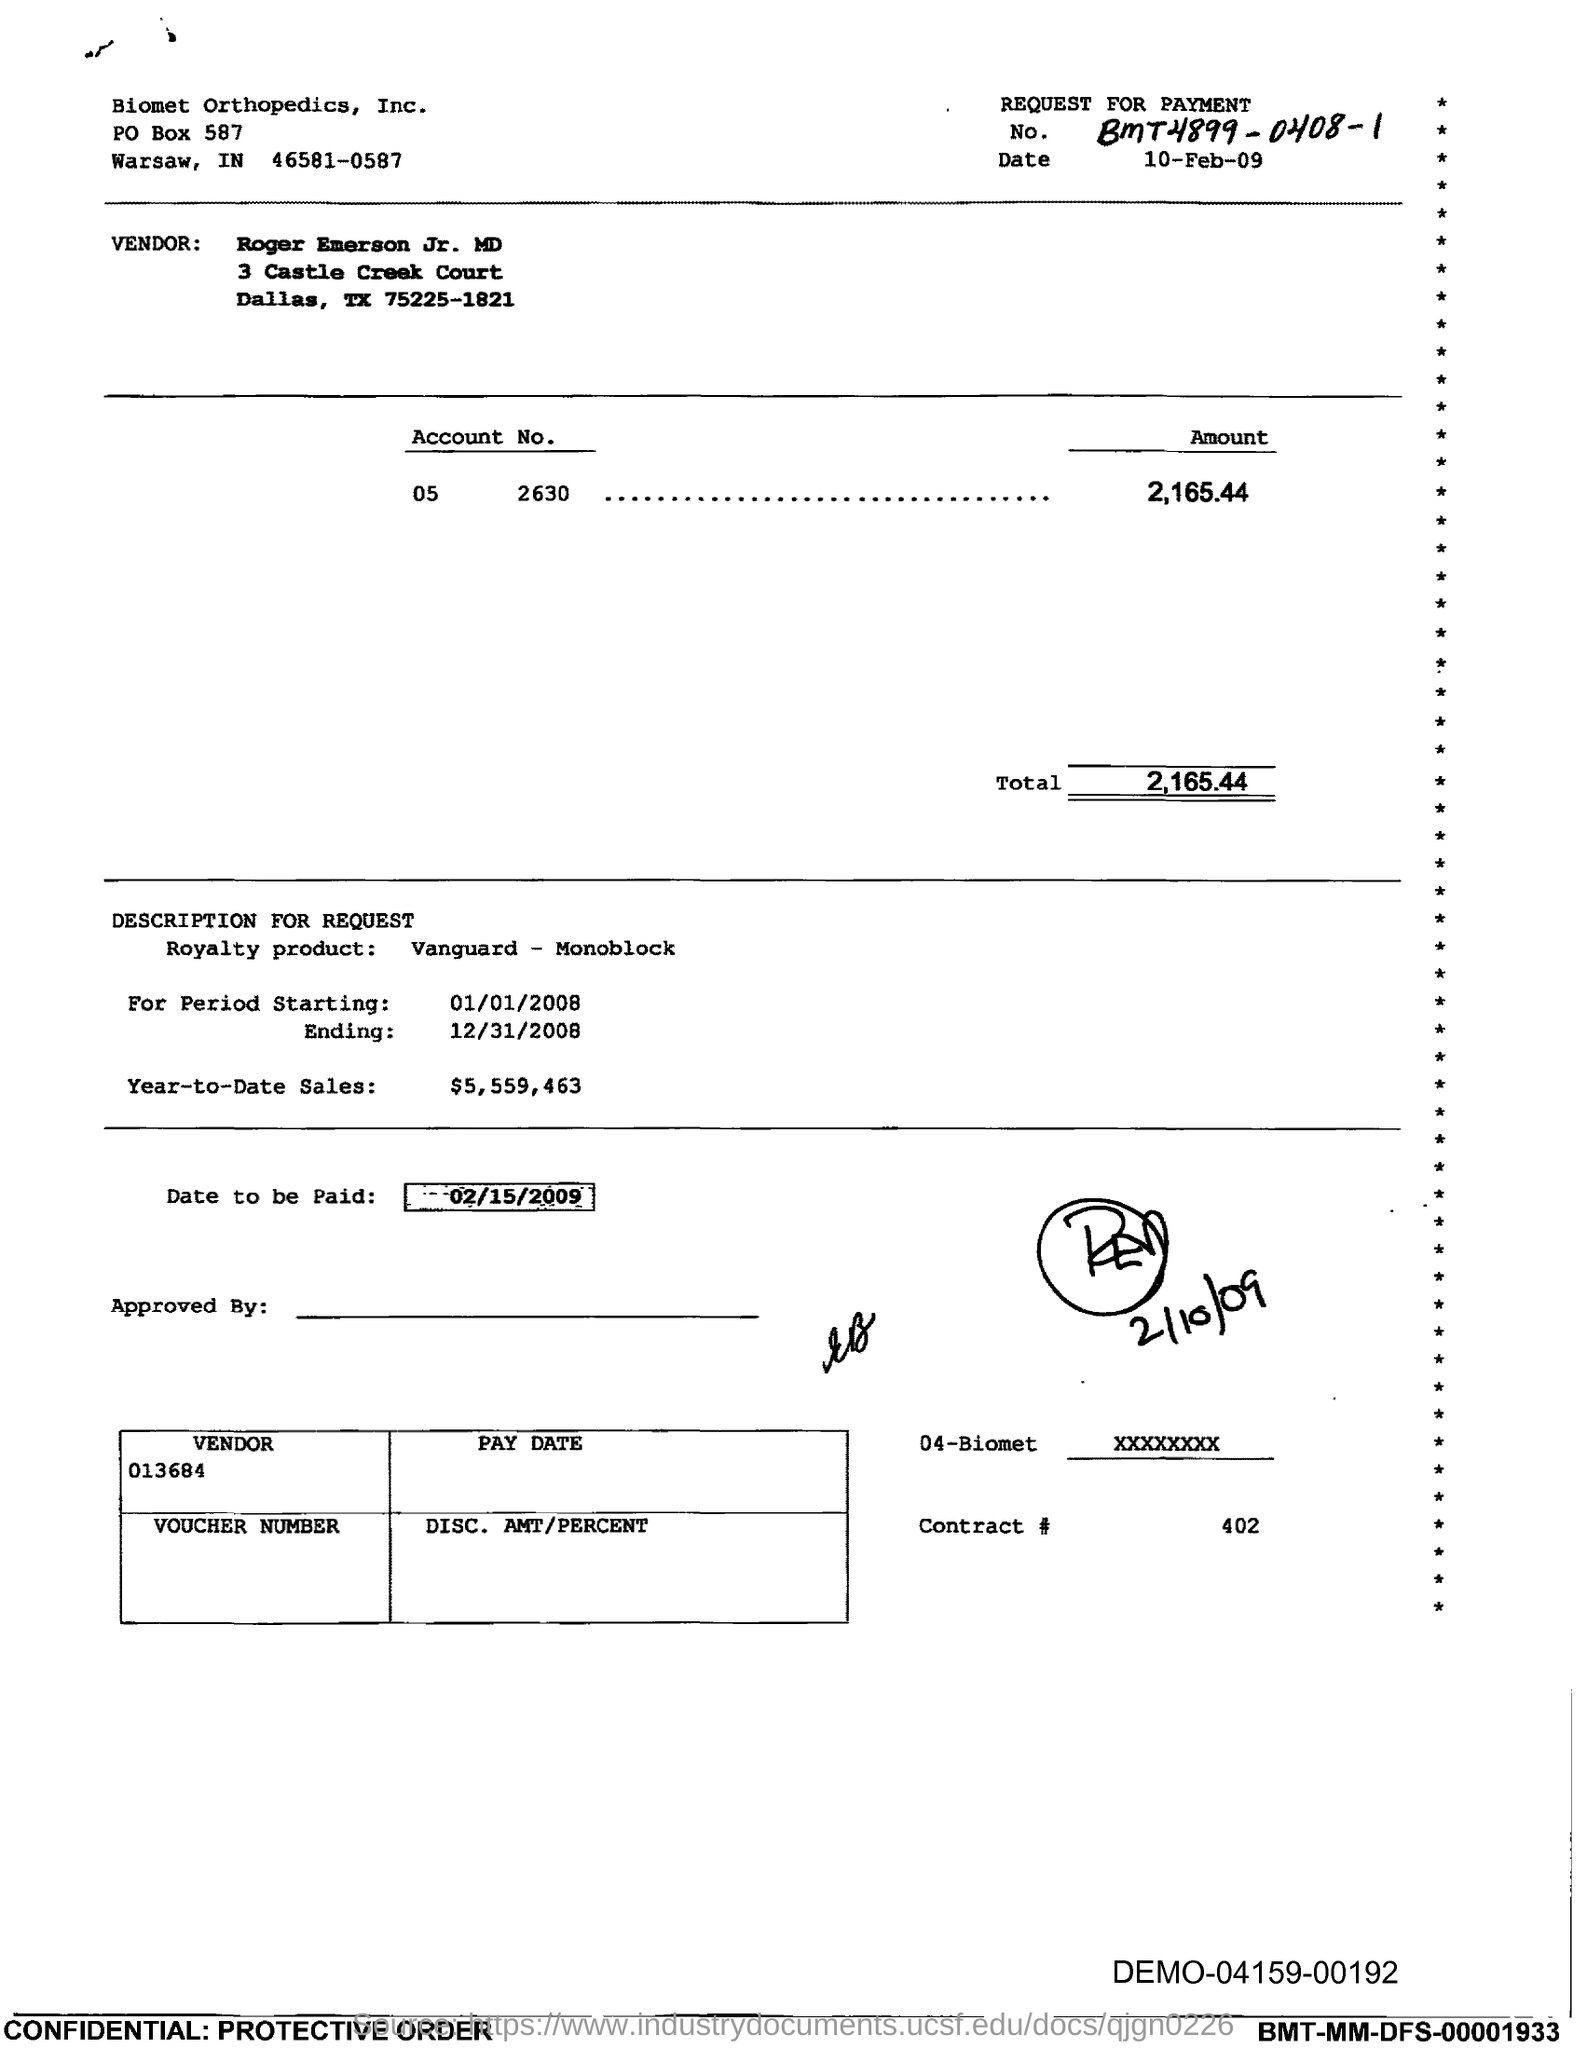What is the No.?
Keep it short and to the point. BMT4899-0408-1. What is the Date?
Offer a terse response. 10-Feb-09. What is the amount for account No. 05 2630?
Your answer should be compact. 2,165.44. What is the starting period?
Offer a very short reply. 01/01/2008. What is the ending period?
Give a very brief answer. 12/31/2008. What is the Year-to-Date Sales?
Provide a succinct answer. $5,559,463. What is the date to be paid?
Offer a terse response. 02/15/2009. 